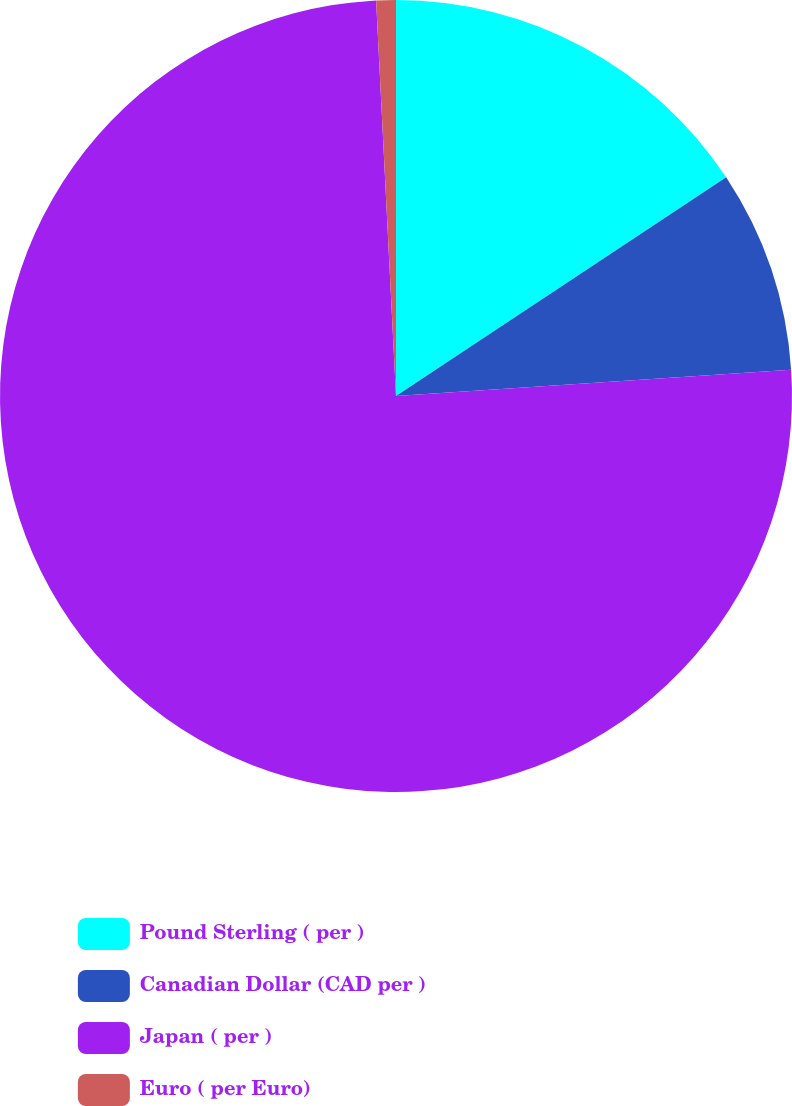Convert chart to OTSL. <chart><loc_0><loc_0><loc_500><loc_500><pie_chart><fcel>Pound Sterling ( per )<fcel>Canadian Dollar (CAD per )<fcel>Japan ( per )<fcel>Euro ( per Euro)<nl><fcel>15.69%<fcel>8.25%<fcel>75.26%<fcel>0.8%<nl></chart> 